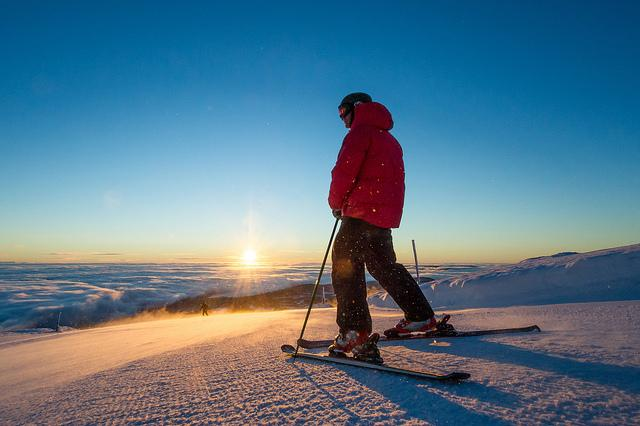Transport using skis to glide on snow is called? Please explain your reasoning. skiing. A person wears skis to either go down a hill or cross country ski and both are done on snow. 